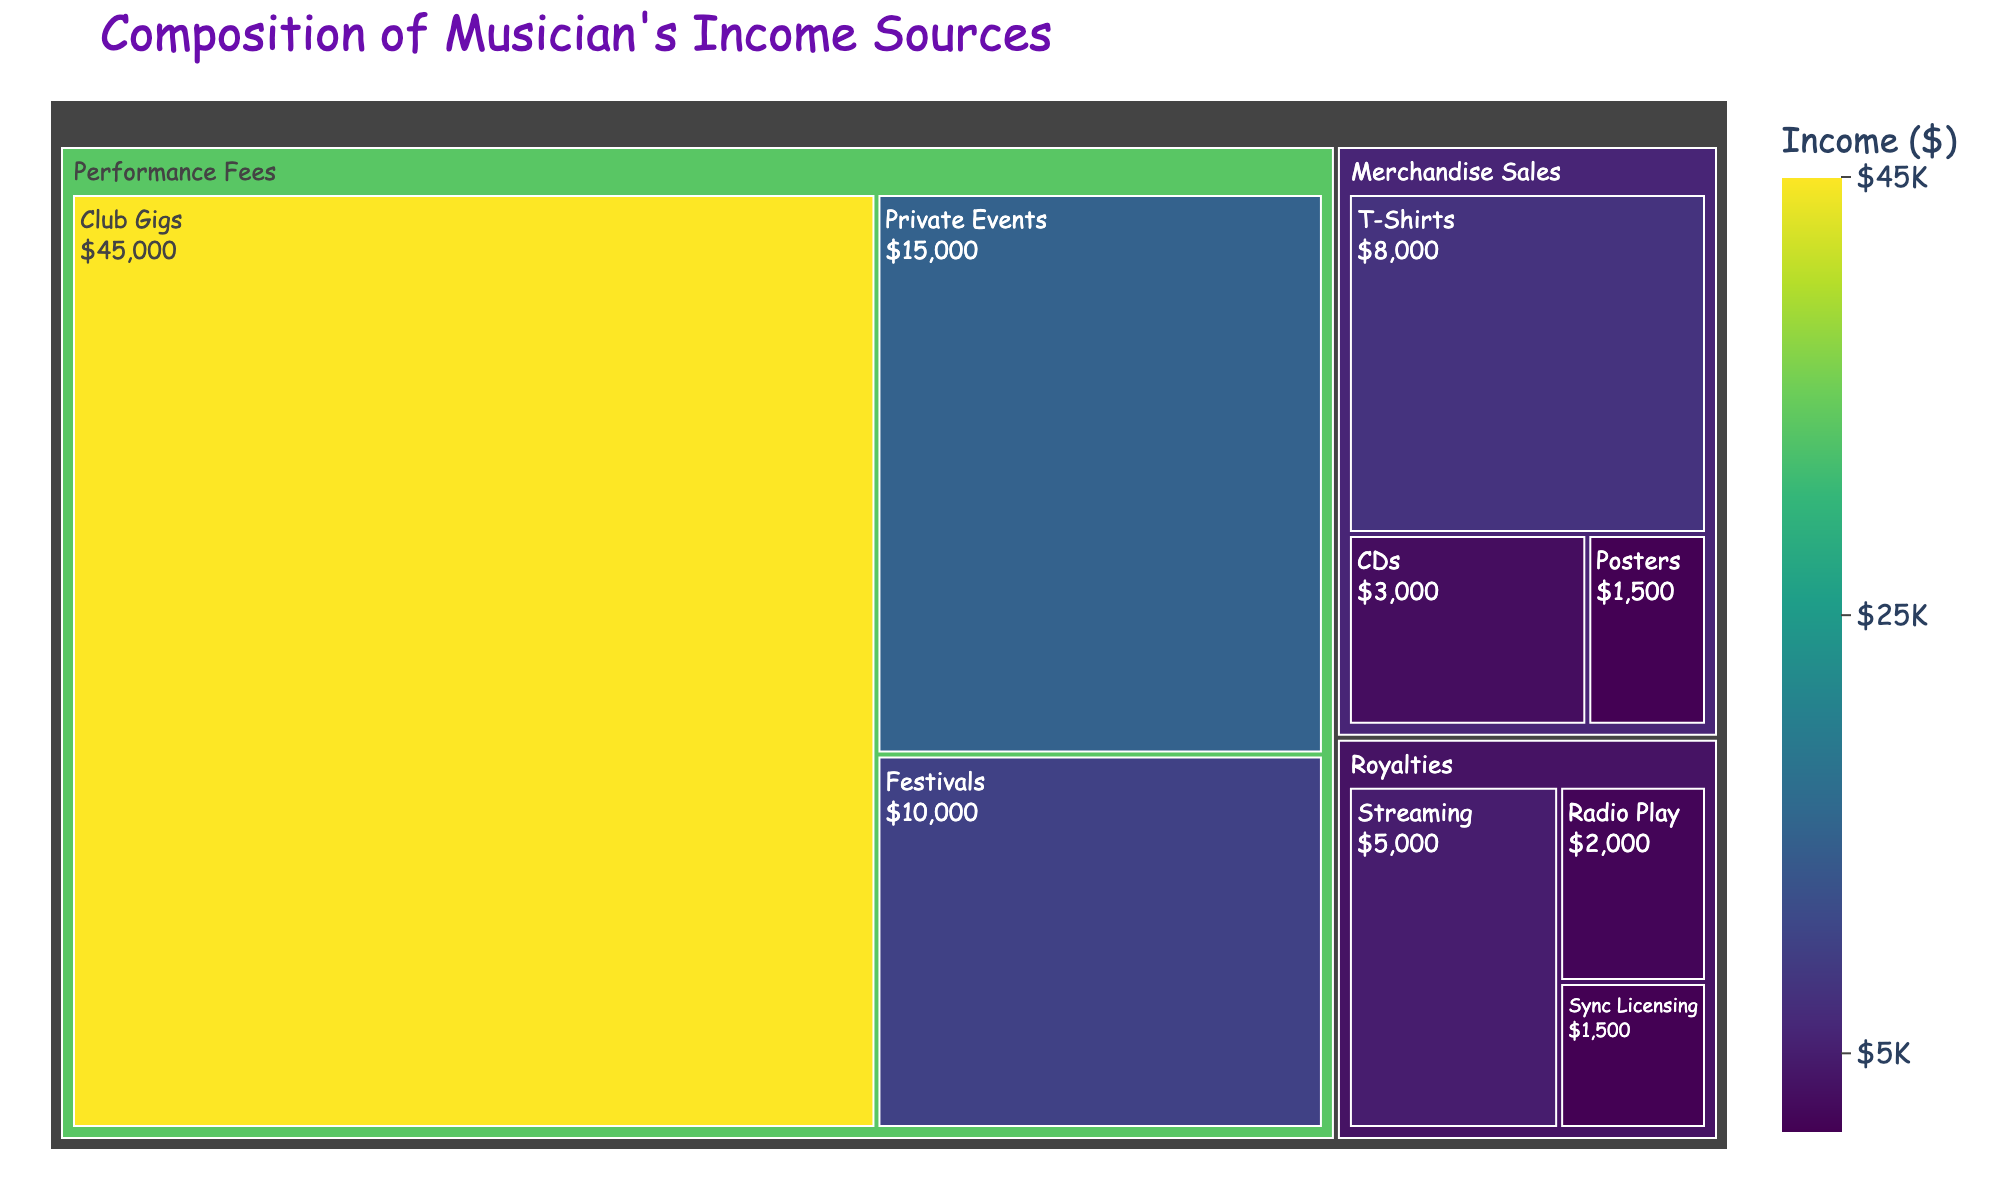What's the largest income source in the Treemap? The largest income source is indicated by the biggest area on the Treemap, which corresponds to Club Gigs under the Performance Fees category.
Answer: Club Gigs What are the total earnings from Performance Fees? To find the total earnings from Performance Fees, we sum the values of Club Gigs ($45,000), Private Events ($15,000), and Festivals ($10,000). So, $45,000 + $15,000 + $10,000 = $70,000.
Answer: $70,000 How do Merchandise Sales compare to Royalties in terms of total value? To compare the total values, we sum the values under Merchandise Sales: T-Shirts ($8,000), CDs ($3,000), and Posters ($1,500) which total to $12,500. For Royalties, we sum Streaming ($5,000), Radio Play ($2,000), and Sync Licensing ($1,500), totaling $8,500. Merchandise Sales ($12,500) are greater than Royalties ($8,500).
Answer: Merchandise Sales are greater Which subcategory has the smallest income? The smallest income is represented by the smallest area on the Treemap, which corresponds to Posters under Merchandise Sales with $1,500.
Answer: Posters What's the combined income from T-Shirts and Streaming? To get the combined income, we sum the values of T-Shirts ($8,000) and Streaming ($5,000). So, $8,000 + $5,000 = $13,000.
Answer: $13,000 Under which main category does the income source 'Sync Licensing' fall? Sync Licensing falls under the main category of Royalties.
Answer: Royalties What's the average income from all subcategories under Royalties? To find the average income from Royalties, sum the values of Streaming ($5,000), Radio Play ($2,000), and Sync Licensing ($1,500) which gives $8,500. The average is $8,500 / 3 = approximately $2,833.
Answer: approximately $2,833 Which income source in Merchandise Sales has the highest value? The highest value in Merchandise Sales is T-Shirts with $8,000.
Answer: T-Shirts Between Club Gigs and Private Events, which income source has a higher value and by how much? Club Gigs is higher than Private Events. To find the difference, subtract the value of Private Events ($15,000) from the value of Club Gigs ($45,000). So, $45,000 - $15,000 = $30,000.
Answer: Club Gigs by $30,000 How many main categories are represented in the Treemap? The Treemap has three main categories: Performance Fees, Merchandise Sales, and Royalties.
Answer: 3 